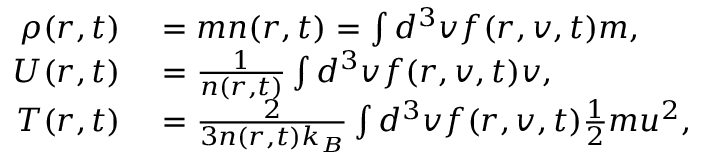Convert formula to latex. <formula><loc_0><loc_0><loc_500><loc_500>\begin{array} { r l } { \rho ( r , t ) } & = m n ( r , t ) = \int d ^ { 3 } v f ( r , v , t ) m , } \\ { U ( r , t ) } & = \frac { 1 } { n ( r , t ) } \int d ^ { 3 } v f ( r , v , t ) v , } \\ { T ( r , t ) } & = \frac { 2 } { 3 n ( r , t ) k _ { B } } \int d ^ { 3 } v f ( r , v , t ) \frac { 1 } { 2 } m u ^ { 2 } , } \end{array}</formula> 